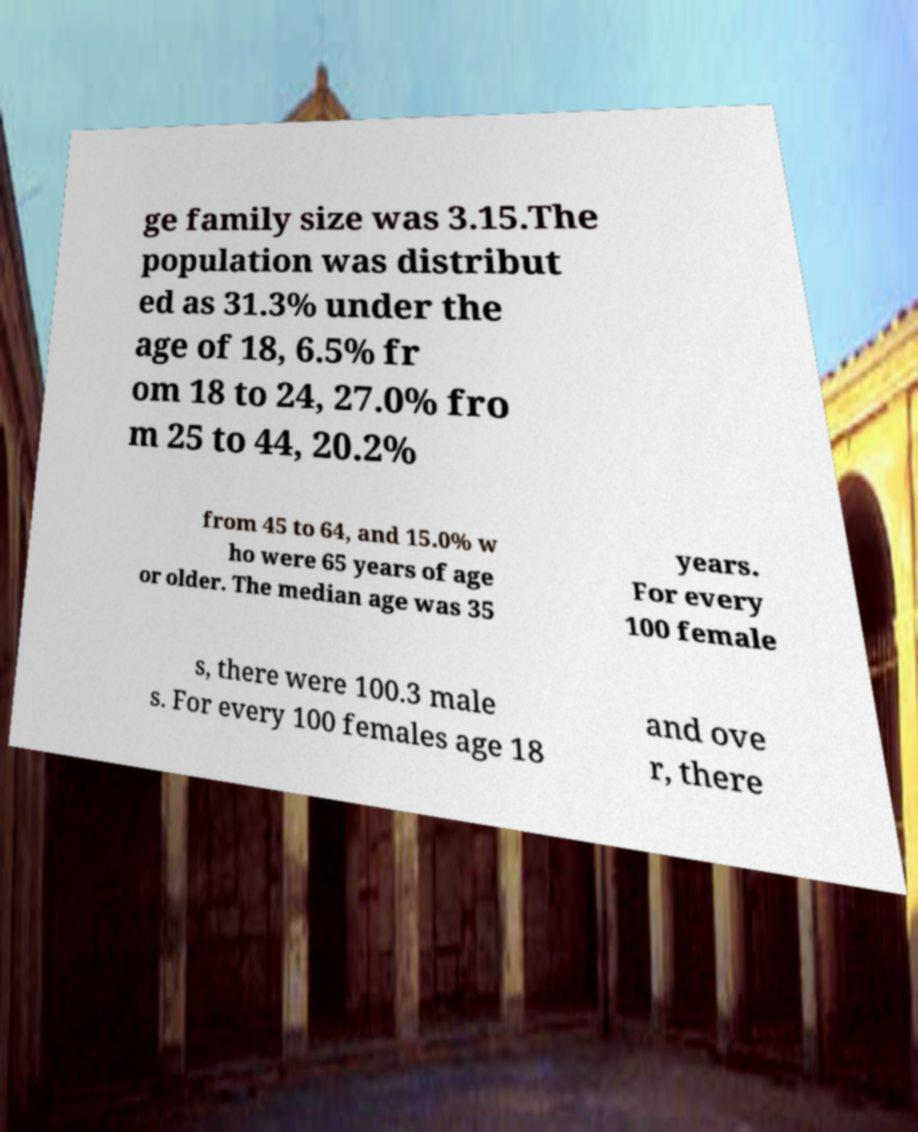There's text embedded in this image that I need extracted. Can you transcribe it verbatim? ge family size was 3.15.The population was distribut ed as 31.3% under the age of 18, 6.5% fr om 18 to 24, 27.0% fro m 25 to 44, 20.2% from 45 to 64, and 15.0% w ho were 65 years of age or older. The median age was 35 years. For every 100 female s, there were 100.3 male s. For every 100 females age 18 and ove r, there 